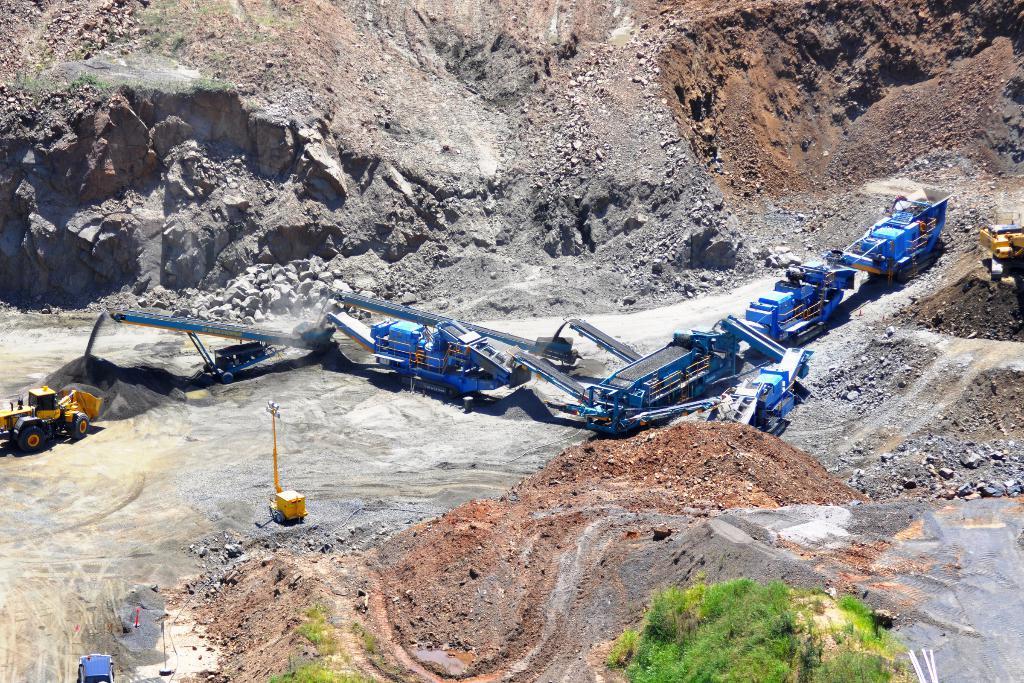Could you give a brief overview of what you see in this image? This image is taken outdoors. In the background there is a hill. There are a few rocks. There are many stones on the ground. In the middle of the image there are many cranes and a few vehicles on the ground. At the bottom of the image there is a ground with grass on it and there are a few plants. 